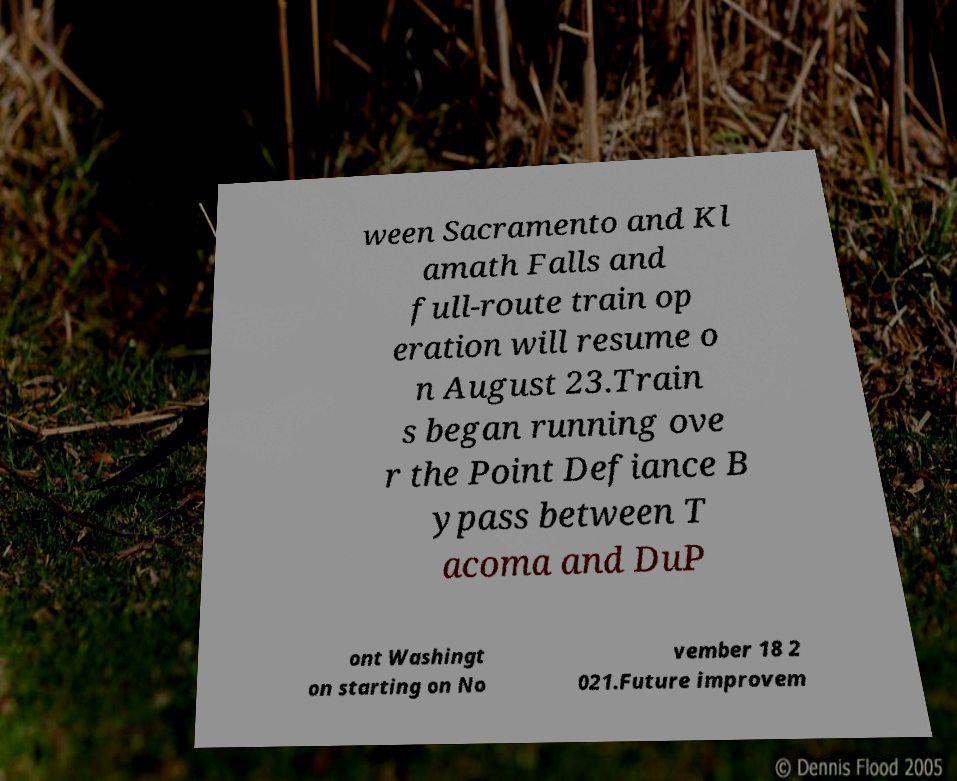Could you extract and type out the text from this image? ween Sacramento and Kl amath Falls and full-route train op eration will resume o n August 23.Train s began running ove r the Point Defiance B ypass between T acoma and DuP ont Washingt on starting on No vember 18 2 021.Future improvem 